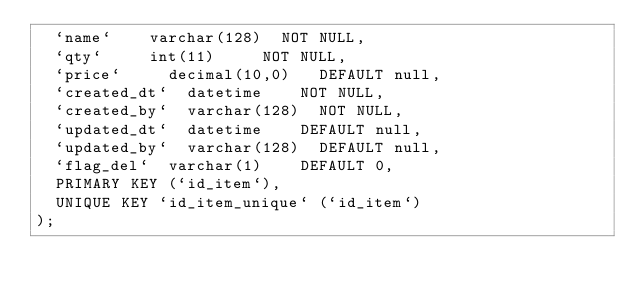<code> <loc_0><loc_0><loc_500><loc_500><_SQL_>  `name` 		varchar(128) 	NOT NULL,
  `qty` 		int(11) 		NOT NULL,
  `price` 		decimal(10,0) 	DEFAULT null,
  `created_dt` 	datetime 		NOT NULL,
  `created_by` 	varchar(128) 	NOT NULL,
  `updated_dt` 	datetime 		DEFAULT null,
  `updated_by` 	varchar(128) 	DEFAULT null,
  `flag_del` 	varchar(1) 		DEFAULT 0,
  PRIMARY KEY (`id_item`),
  UNIQUE KEY `id_item_unique` (`id_item`)
);
</code> 